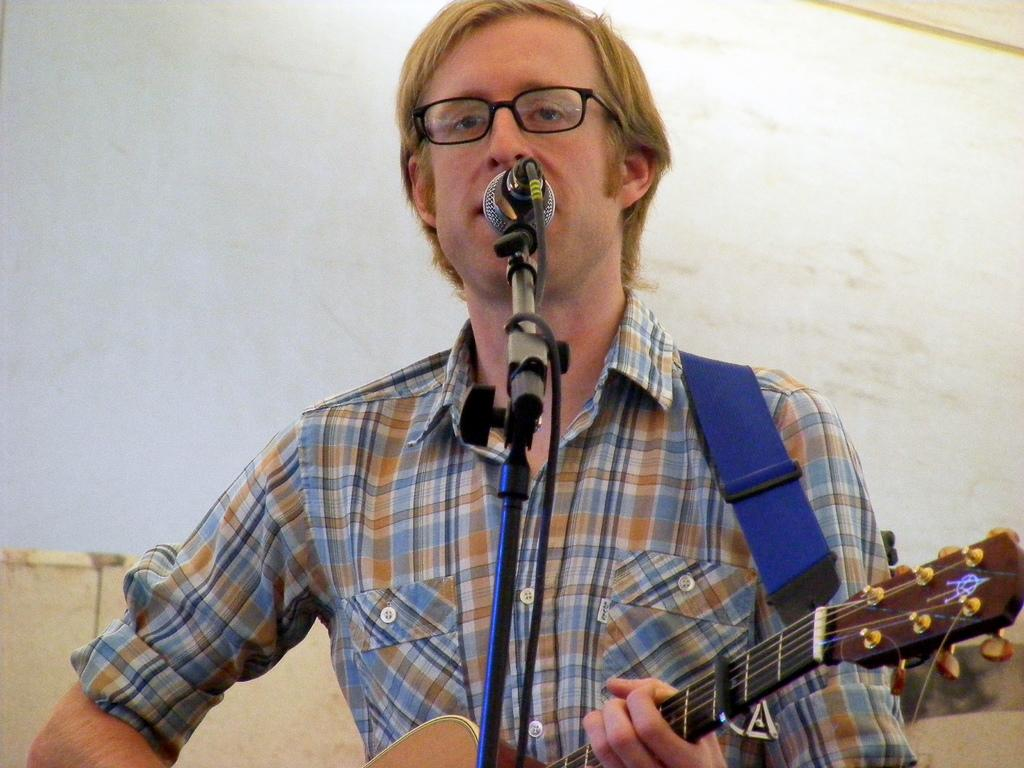Who is the main subject in the image? There is a man in the image. What accessories is the man wearing? The man is wearing glasses and a shirt. What is the man holding in the image? The man is holding a guitar. What object is in front of the man? There is a microphone in front of the man. What can be seen in the background of the image? There is a wall in the background of the image. What type of shoes is the man wearing in the image? The provided facts do not mention shoes, so we cannot determine the type of shoes the man is wearing. 